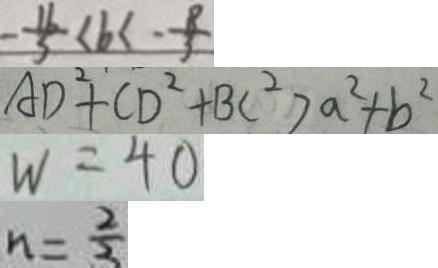<formula> <loc_0><loc_0><loc_500><loc_500>- \frac { 1 6 } { 5 } < b < - \frac { 8 } { 3 } 
 A D ^ { 2 } + C D ^ { 2 } + B C ^ { 2 } > a ^ { 2 } + b ^ { 2 } 
 W = 4 0 
 n = \frac { 2 } { 3 }</formula> 